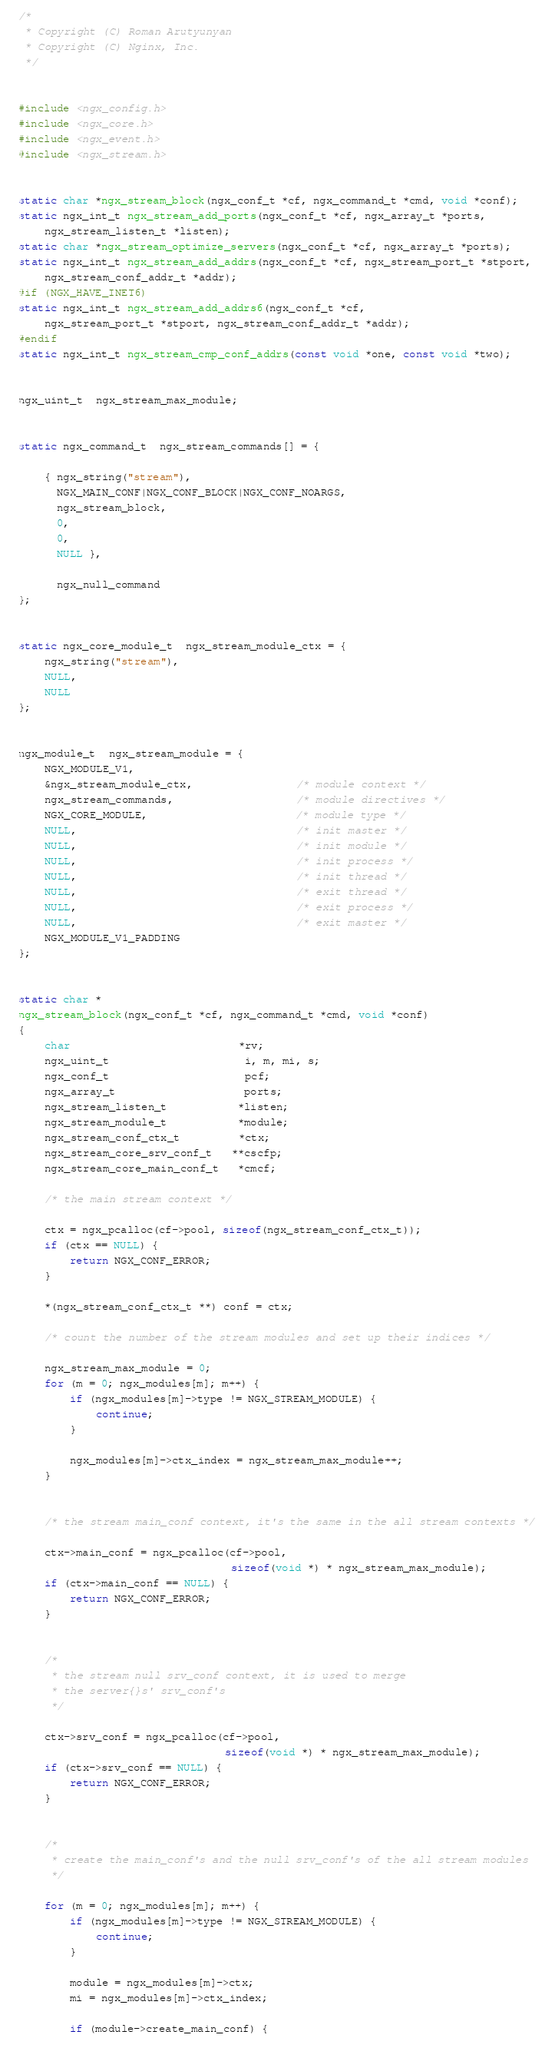<code> <loc_0><loc_0><loc_500><loc_500><_C_>
/*
 * Copyright (C) Roman Arutyunyan
 * Copyright (C) Nginx, Inc.
 */


#include <ngx_config.h>
#include <ngx_core.h>
#include <ngx_event.h>
#include <ngx_stream.h>


static char *ngx_stream_block(ngx_conf_t *cf, ngx_command_t *cmd, void *conf);
static ngx_int_t ngx_stream_add_ports(ngx_conf_t *cf, ngx_array_t *ports,
    ngx_stream_listen_t *listen);
static char *ngx_stream_optimize_servers(ngx_conf_t *cf, ngx_array_t *ports);
static ngx_int_t ngx_stream_add_addrs(ngx_conf_t *cf, ngx_stream_port_t *stport,
    ngx_stream_conf_addr_t *addr);
#if (NGX_HAVE_INET6)
static ngx_int_t ngx_stream_add_addrs6(ngx_conf_t *cf,
    ngx_stream_port_t *stport, ngx_stream_conf_addr_t *addr);
#endif
static ngx_int_t ngx_stream_cmp_conf_addrs(const void *one, const void *two);


ngx_uint_t  ngx_stream_max_module;


static ngx_command_t  ngx_stream_commands[] = {

    { ngx_string("stream"),
      NGX_MAIN_CONF|NGX_CONF_BLOCK|NGX_CONF_NOARGS,
      ngx_stream_block,
      0,
      0,
      NULL },

      ngx_null_command
};


static ngx_core_module_t  ngx_stream_module_ctx = {
    ngx_string("stream"),
    NULL,
    NULL
};


ngx_module_t  ngx_stream_module = {
    NGX_MODULE_V1,
    &ngx_stream_module_ctx,                /* module context */
    ngx_stream_commands,                   /* module directives */
    NGX_CORE_MODULE,                       /* module type */
    NULL,                                  /* init master */
    NULL,                                  /* init module */
    NULL,                                  /* init process */
    NULL,                                  /* init thread */
    NULL,                                  /* exit thread */
    NULL,                                  /* exit process */
    NULL,                                  /* exit master */
    NGX_MODULE_V1_PADDING
};


static char *
ngx_stream_block(ngx_conf_t *cf, ngx_command_t *cmd, void *conf)
{
    char                          *rv;
    ngx_uint_t                     i, m, mi, s;
    ngx_conf_t                     pcf;
    ngx_array_t                    ports;
    ngx_stream_listen_t           *listen;
    ngx_stream_module_t           *module;
    ngx_stream_conf_ctx_t         *ctx;
    ngx_stream_core_srv_conf_t   **cscfp;
    ngx_stream_core_main_conf_t   *cmcf;

    /* the main stream context */

    ctx = ngx_pcalloc(cf->pool, sizeof(ngx_stream_conf_ctx_t));
    if (ctx == NULL) {
        return NGX_CONF_ERROR;
    }

    *(ngx_stream_conf_ctx_t **) conf = ctx;

    /* count the number of the stream modules and set up their indices */

    ngx_stream_max_module = 0;
    for (m = 0; ngx_modules[m]; m++) {
        if (ngx_modules[m]->type != NGX_STREAM_MODULE) {
            continue;
        }

        ngx_modules[m]->ctx_index = ngx_stream_max_module++;
    }


    /* the stream main_conf context, it's the same in the all stream contexts */

    ctx->main_conf = ngx_pcalloc(cf->pool,
                                 sizeof(void *) * ngx_stream_max_module);
    if (ctx->main_conf == NULL) {
        return NGX_CONF_ERROR;
    }


    /*
     * the stream null srv_conf context, it is used to merge
     * the server{}s' srv_conf's
     */

    ctx->srv_conf = ngx_pcalloc(cf->pool,
                                sizeof(void *) * ngx_stream_max_module);
    if (ctx->srv_conf == NULL) {
        return NGX_CONF_ERROR;
    }


    /*
     * create the main_conf's and the null srv_conf's of the all stream modules
     */

    for (m = 0; ngx_modules[m]; m++) {
        if (ngx_modules[m]->type != NGX_STREAM_MODULE) {
            continue;
        }

        module = ngx_modules[m]->ctx;
        mi = ngx_modules[m]->ctx_index;

        if (module->create_main_conf) {</code> 